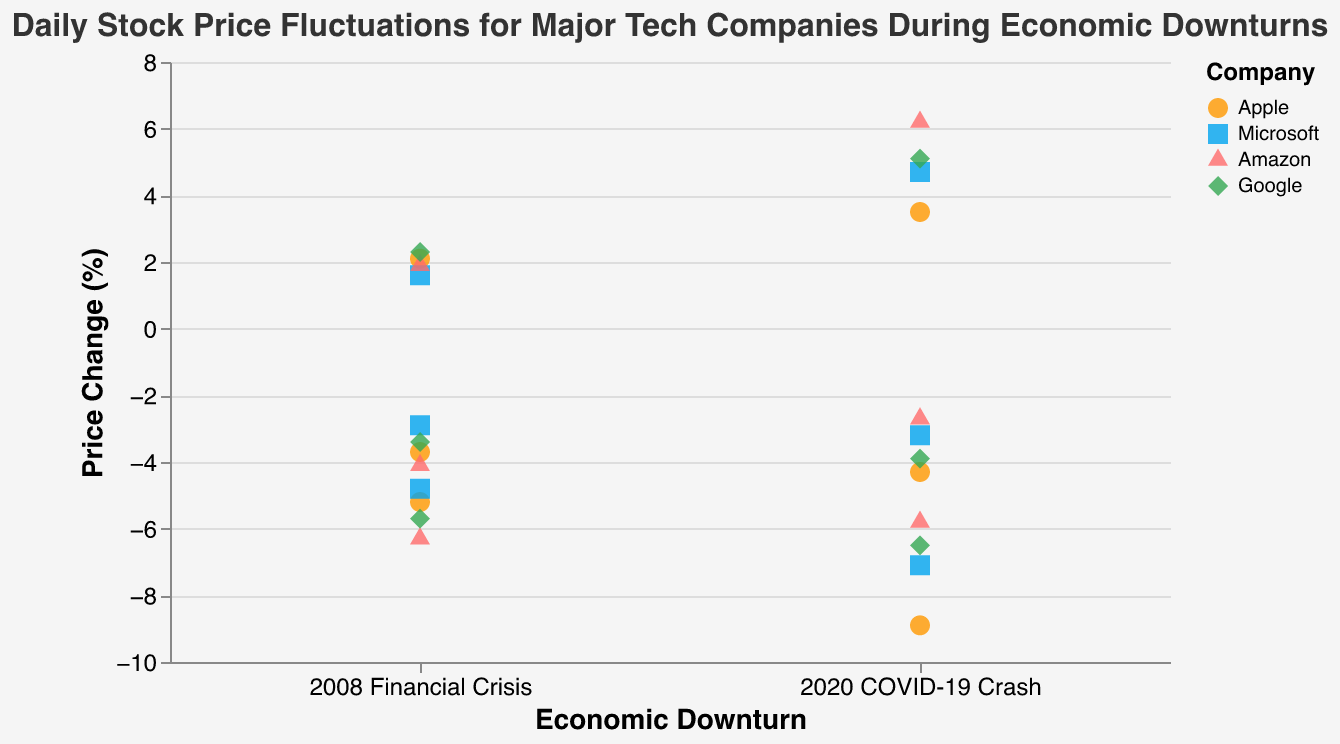What is the title of the figure? The title is displayed at the top of the figure in a larger font size.
Answer: Daily Stock Price Fluctuations for Major Tech Companies During Economic Downturns What are the companies represented in the figure? The legend on the right side of the figure shows different companies represented by different colors and shapes.
Answer: Apple, Microsoft, Amazon, Google Which company experienced the largest negative price change during the 2020 COVID-19 Crash? Find the lowest point in the Price_Change axis under the "2020 COVID-19 Crash" category and note the corresponding company. In this case, it's Apple with a -8.9% change.
Answer: Apple How many data points correspond to Apple during the 2008 Financial Crisis? The points corresponding to Apple under "2008 Financial Crisis" can be counted directly. There are three dots for Apple.
Answer: 3 What is the average price change for Microsoft during the 2008 Financial Crisis? The three price changes for Microsoft in 2008 Financial Crisis are -4.8, -2.9, and 1.6. Sum them up (-4.8 + -2.9 + 1.6 = -6.1) and divide by 3: -6.1 / 3 = -2.03
Answer: -2.03 Between Apple and Google, which company had a greater positive price change during the 2020 COVID-19 Crash? Compare the highest positive price change for Apple and Google under the "2020 COVID-19 Crash". Apple has 3.5% and Google has 5.1%. Therefore, Google has the greater positive price change.
Answer: Google For Amazon, how does the average price change during the 2008 Financial Crisis compare to the 2020 COVID-19 Crash? Calculate averages for both periods. For 2008: (-6.3 + -4.1 + 1.9 = -8.5) / 3 = -2.83. For 2020: (-5.8 + -2.7 + 6.2 = -2.3) / 3 = -0.77. The average during the 2008 Financial Crisis is more negative.
Answer: The 2008 Financial Crisis average is more negative Which economic downturn shows more scattered data points among all companies? Look at the spread of data points along the Price_Change axis for both downturns. Both have a spread, but the 2020 COVID-19 Crash shows a slightly more scattered distribution.
Answer: 2020 COVID-19 Crash 